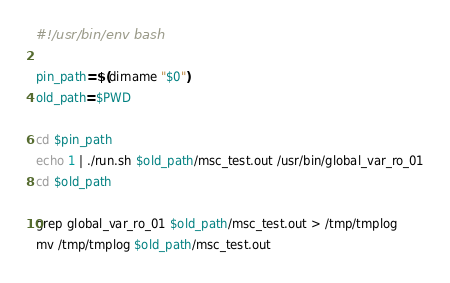Convert code to text. <code><loc_0><loc_0><loc_500><loc_500><_Bash_>#!/usr/bin/env bash

pin_path=$(dirname "$0")
old_path=$PWD

cd $pin_path
echo 1 | ./run.sh $old_path/msc_test.out /usr/bin/global_var_ro_01
cd $old_path

grep global_var_ro_01 $old_path/msc_test.out > /tmp/tmplog
mv /tmp/tmplog $old_path/msc_test.out
</code> 